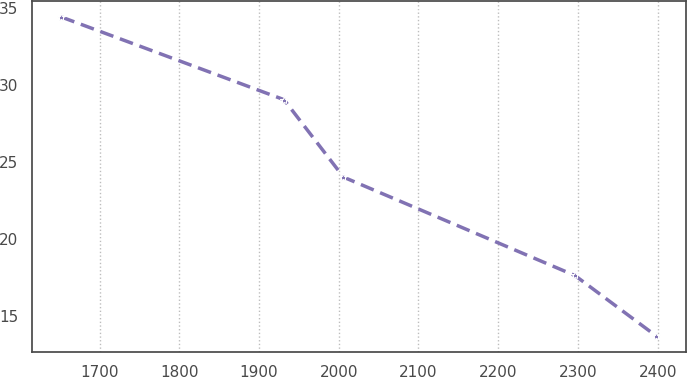Convert chart to OTSL. <chart><loc_0><loc_0><loc_500><loc_500><line_chart><ecel><fcel>Unnamed: 1<nl><fcel>1651.97<fcel>34.44<nl><fcel>1931.32<fcel>29.06<nl><fcel>2005.95<fcel>24.02<nl><fcel>2296.16<fcel>17.62<nl><fcel>2398.28<fcel>13.68<nl></chart> 